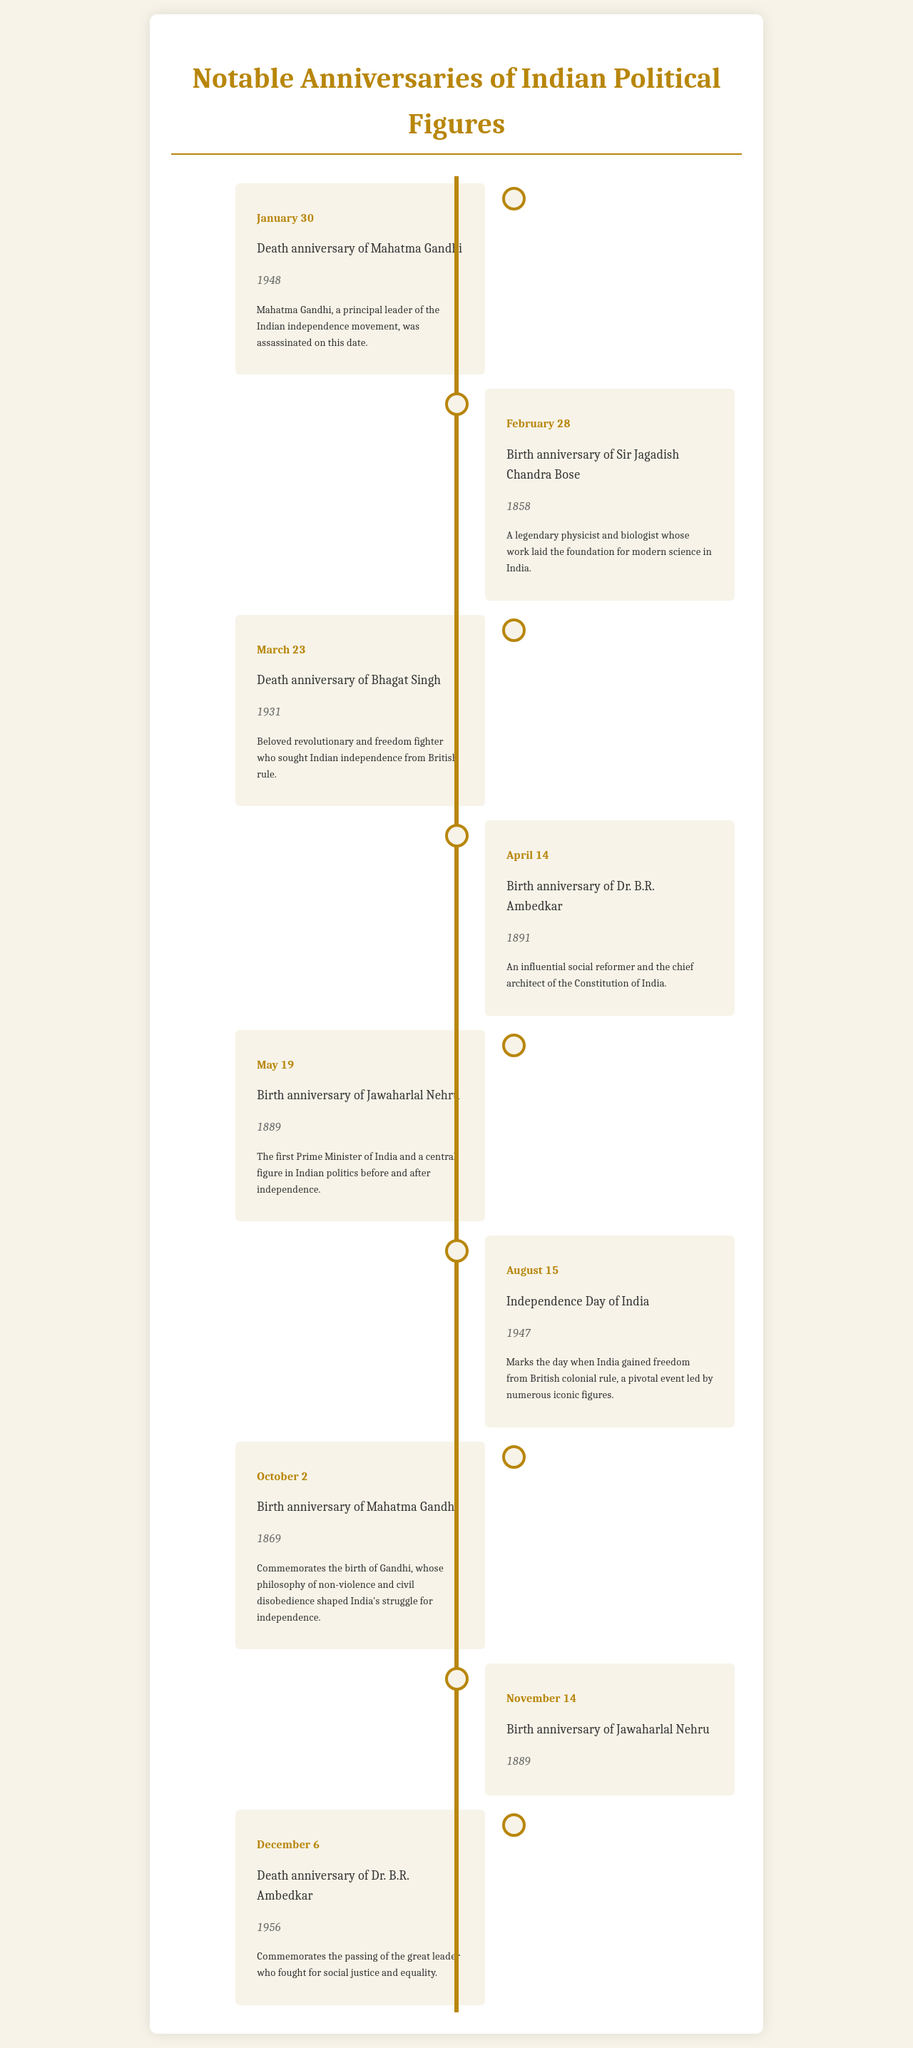What date marks the death anniversary of Mahatma Gandhi? The document states that Mahatma Gandhi's death anniversary is on January 30.
Answer: January 30 When was Dr. B.R. Ambedkar born? The schedule indicates that Dr. B.R. Ambedkar was born on April 14, 1891.
Answer: April 14, 1891 Who is commemorated on August 15? The document shows that August 15 is recognized as India's Independence Day.
Answer: Independence Day of India What year did Bhagat Singh die? The entry for Bhagat Singh mentions his death year as 1931.
Answer: 1931 On which date is the birth anniversary of Jawaharlal Nehru celebrated? The schedule lists Jawaharlal Nehru's birth anniversary date as May 19.
Answer: May 19 Which political figure's birth anniversary is on October 2? According to the document, Mahatma Gandhi's birth anniversary is on October 2.
Answer: Mahatma Gandhi How many events are listed for November? The document shows that there is one event listed for November, specifically the birth anniversary of Jawaharlal Nehru.
Answer: One What common theme is presented across the anniversaries in this document? The document focuses on notable anniversaries of iconic political figures in India.
Answer: Notable anniversaries of iconic political figures in India What key social issue was Dr. B.R. Ambedkar associated with? The schedule describes him as a leader who fought for social justice and equality.
Answer: Social justice and equality 